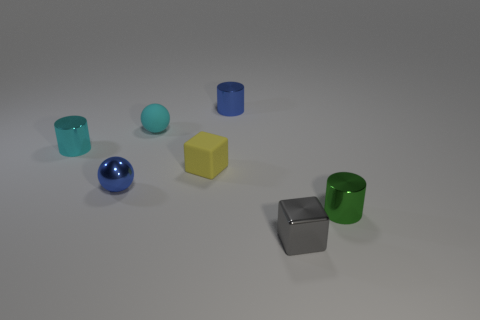Are there fewer green cylinders that are in front of the blue cylinder than tiny cyan metal cylinders to the right of the tiny blue ball?
Make the answer very short. No. There is another object that is the same shape as the yellow thing; what material is it?
Your response must be concise. Metal. Are there any other things that have the same material as the yellow block?
Your response must be concise. Yes. Is the color of the metal block the same as the rubber ball?
Your answer should be very brief. No. There is a thing that is the same material as the tiny yellow block; what is its shape?
Your answer should be compact. Sphere. How many small blue things have the same shape as the green metallic thing?
Offer a terse response. 1. There is a small cyan object on the right side of the small ball that is in front of the small rubber ball; what shape is it?
Your response must be concise. Sphere. Does the block that is behind the gray thing have the same size as the small cyan rubber object?
Give a very brief answer. Yes. There is a metal thing that is both behind the small green metal object and in front of the small cyan metallic object; what is its size?
Your answer should be very brief. Small. What number of cyan shiny objects are the same size as the shiny block?
Keep it short and to the point. 1. 